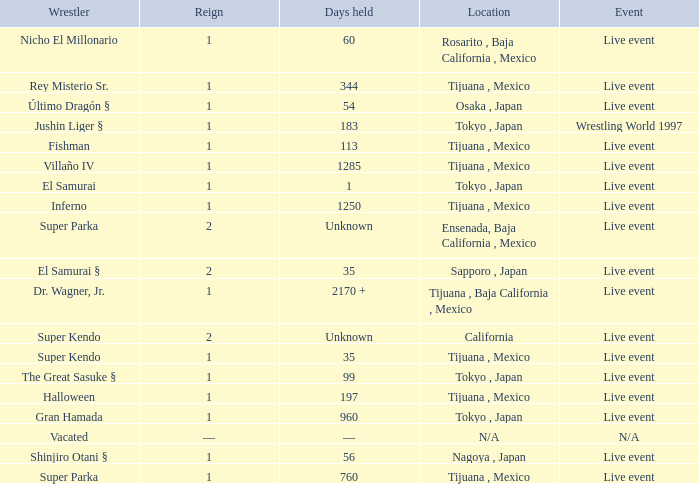What is the reign for super kendo who held it for 35 days? 1.0. 